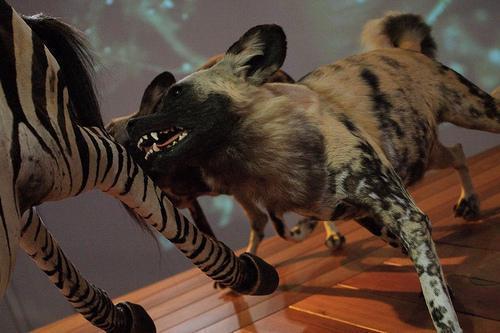How many animals are shown?
Give a very brief answer. 3. 